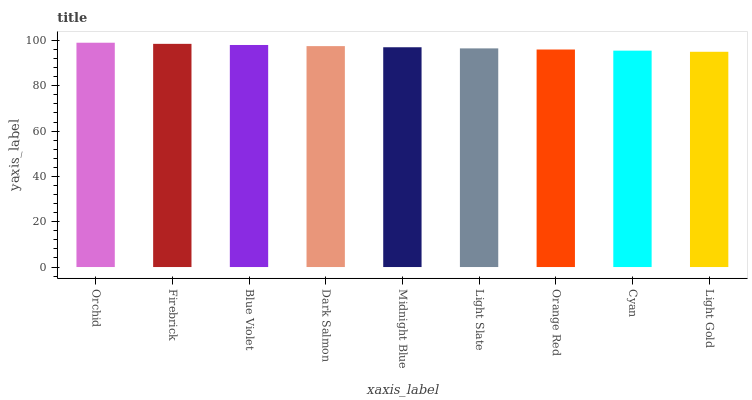Is Light Gold the minimum?
Answer yes or no. Yes. Is Orchid the maximum?
Answer yes or no. Yes. Is Firebrick the minimum?
Answer yes or no. No. Is Firebrick the maximum?
Answer yes or no. No. Is Orchid greater than Firebrick?
Answer yes or no. Yes. Is Firebrick less than Orchid?
Answer yes or no. Yes. Is Firebrick greater than Orchid?
Answer yes or no. No. Is Orchid less than Firebrick?
Answer yes or no. No. Is Midnight Blue the high median?
Answer yes or no. Yes. Is Midnight Blue the low median?
Answer yes or no. Yes. Is Firebrick the high median?
Answer yes or no. No. Is Orchid the low median?
Answer yes or no. No. 